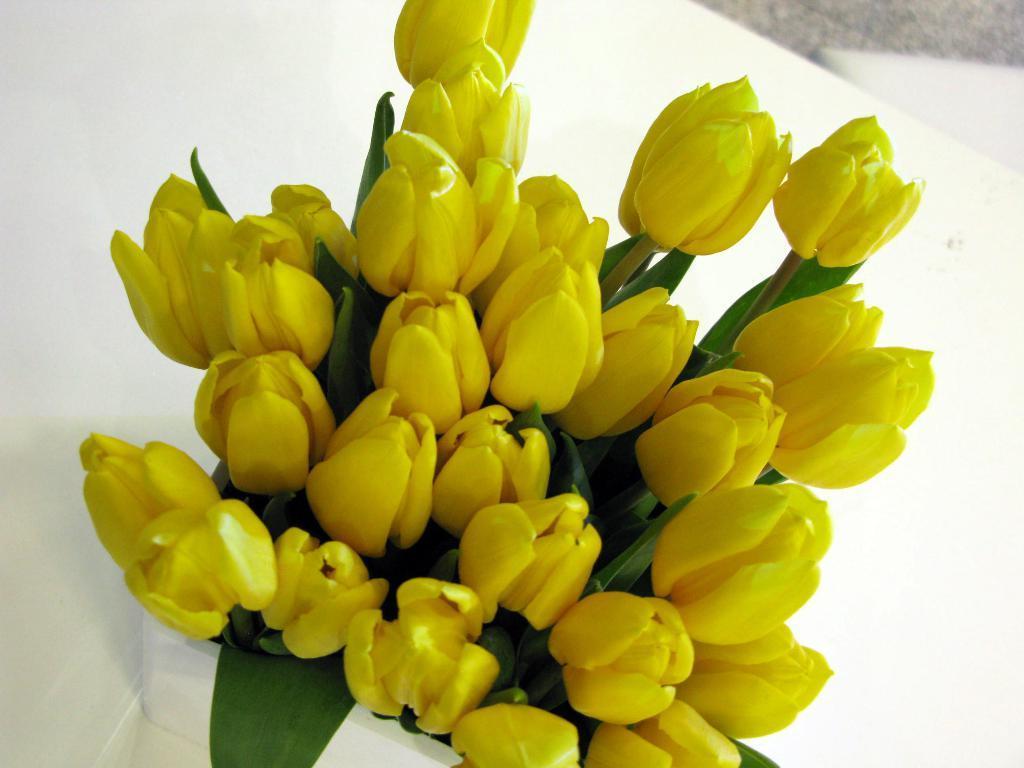Describe this image in one or two sentences. In this picture we can see a pot on the white surface. We can see yellow flowers, green leaves and stems. 